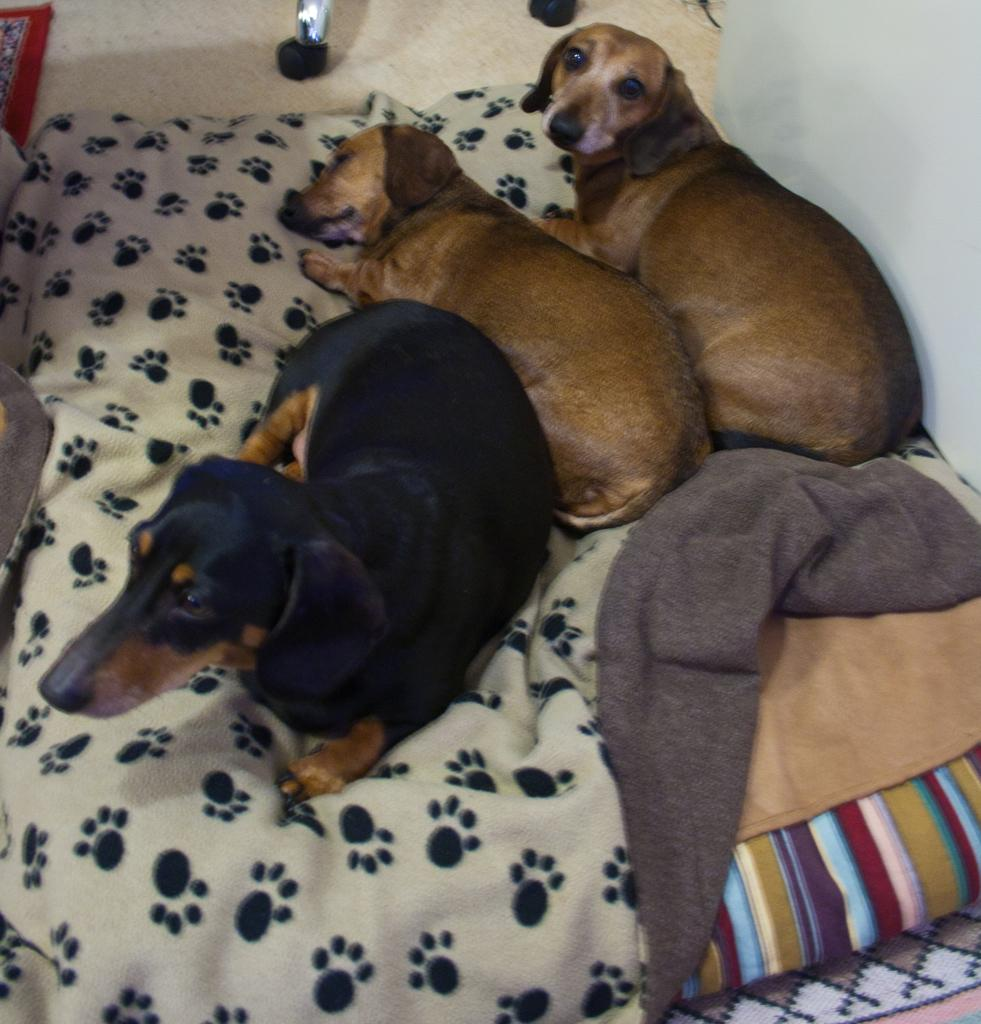What type of animals are in the image? There are dogs in the image. Where are the dogs located? The dogs are on a bed. What type of cloud can be seen in the image? There is no cloud present in the image; it features dogs on a bed. What is the income of the person who owns the dogs in the image? The income of the person who owns the dogs cannot be determined from the image. 